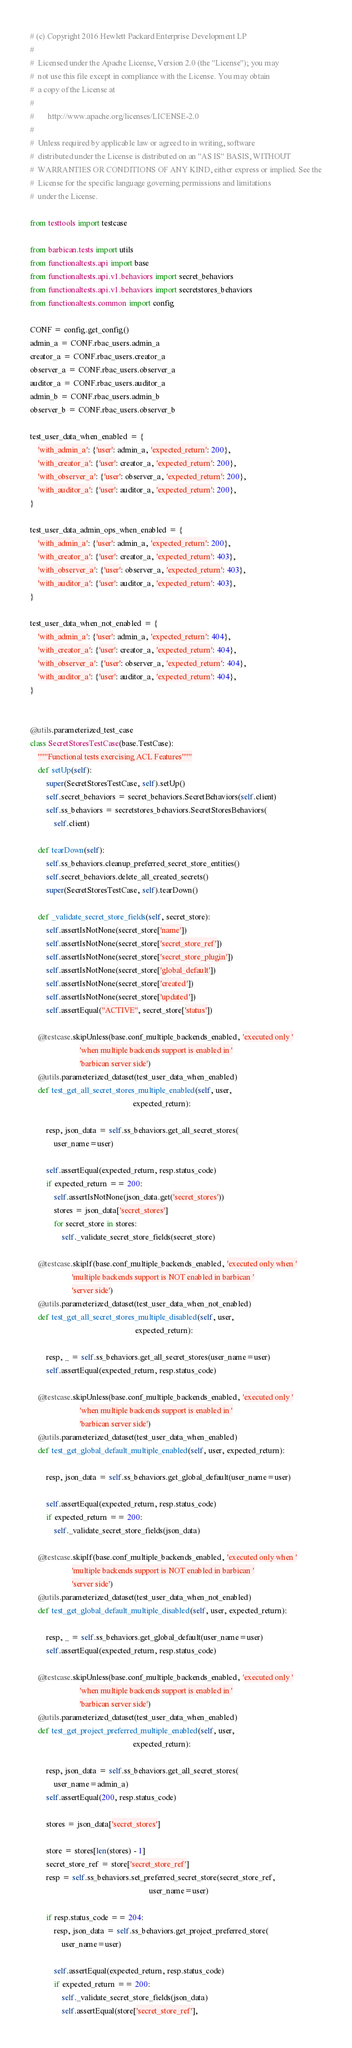Convert code to text. <code><loc_0><loc_0><loc_500><loc_500><_Python_># (c) Copyright 2016 Hewlett Packard Enterprise Development LP
#
#  Licensed under the Apache License, Version 2.0 (the "License"); you may
#  not use this file except in compliance with the License. You may obtain
#  a copy of the License at
#
#       http://www.apache.org/licenses/LICENSE-2.0
#
#  Unless required by applicable law or agreed to in writing, software
#  distributed under the License is distributed on an "AS IS" BASIS, WITHOUT
#  WARRANTIES OR CONDITIONS OF ANY KIND, either express or implied. See the
#  License for the specific language governing permissions and limitations
#  under the License.

from testtools import testcase

from barbican.tests import utils
from functionaltests.api import base
from functionaltests.api.v1.behaviors import secret_behaviors
from functionaltests.api.v1.behaviors import secretstores_behaviors
from functionaltests.common import config

CONF = config.get_config()
admin_a = CONF.rbac_users.admin_a
creator_a = CONF.rbac_users.creator_a
observer_a = CONF.rbac_users.observer_a
auditor_a = CONF.rbac_users.auditor_a
admin_b = CONF.rbac_users.admin_b
observer_b = CONF.rbac_users.observer_b

test_user_data_when_enabled = {
    'with_admin_a': {'user': admin_a, 'expected_return': 200},
    'with_creator_a': {'user': creator_a, 'expected_return': 200},
    'with_observer_a': {'user': observer_a, 'expected_return': 200},
    'with_auditor_a': {'user': auditor_a, 'expected_return': 200},
}

test_user_data_admin_ops_when_enabled = {
    'with_admin_a': {'user': admin_a, 'expected_return': 200},
    'with_creator_a': {'user': creator_a, 'expected_return': 403},
    'with_observer_a': {'user': observer_a, 'expected_return': 403},
    'with_auditor_a': {'user': auditor_a, 'expected_return': 403},
}

test_user_data_when_not_enabled = {
    'with_admin_a': {'user': admin_a, 'expected_return': 404},
    'with_creator_a': {'user': creator_a, 'expected_return': 404},
    'with_observer_a': {'user': observer_a, 'expected_return': 404},
    'with_auditor_a': {'user': auditor_a, 'expected_return': 404},
}


@utils.parameterized_test_case
class SecretStoresTestCase(base.TestCase):
    """Functional tests exercising ACL Features"""
    def setUp(self):
        super(SecretStoresTestCase, self).setUp()
        self.secret_behaviors = secret_behaviors.SecretBehaviors(self.client)
        self.ss_behaviors = secretstores_behaviors.SecretStoresBehaviors(
            self.client)

    def tearDown(self):
        self.ss_behaviors.cleanup_preferred_secret_store_entities()
        self.secret_behaviors.delete_all_created_secrets()
        super(SecretStoresTestCase, self).tearDown()

    def _validate_secret_store_fields(self, secret_store):
        self.assertIsNotNone(secret_store['name'])
        self.assertIsNotNone(secret_store['secret_store_ref'])
        self.assertIsNotNone(secret_store['secret_store_plugin'])
        self.assertIsNotNone(secret_store['global_default'])
        self.assertIsNotNone(secret_store['created'])
        self.assertIsNotNone(secret_store['updated'])
        self.assertEqual("ACTIVE", secret_store['status'])

    @testcase.skipUnless(base.conf_multiple_backends_enabled, 'executed only '
                         'when multiple backends support is enabled in '
                         'barbican server side')
    @utils.parameterized_dataset(test_user_data_when_enabled)
    def test_get_all_secret_stores_multiple_enabled(self, user,
                                                    expected_return):

        resp, json_data = self.ss_behaviors.get_all_secret_stores(
            user_name=user)

        self.assertEqual(expected_return, resp.status_code)
        if expected_return == 200:
            self.assertIsNotNone(json_data.get('secret_stores'))
            stores = json_data['secret_stores']
            for secret_store in stores:
                self._validate_secret_store_fields(secret_store)

    @testcase.skipIf(base.conf_multiple_backends_enabled, 'executed only when '
                     'multiple backends support is NOT enabled in barbican '
                     'server side')
    @utils.parameterized_dataset(test_user_data_when_not_enabled)
    def test_get_all_secret_stores_multiple_disabled(self, user,
                                                     expected_return):

        resp, _ = self.ss_behaviors.get_all_secret_stores(user_name=user)
        self.assertEqual(expected_return, resp.status_code)

    @testcase.skipUnless(base.conf_multiple_backends_enabled, 'executed only '
                         'when multiple backends support is enabled in '
                         'barbican server side')
    @utils.parameterized_dataset(test_user_data_when_enabled)
    def test_get_global_default_multiple_enabled(self, user, expected_return):

        resp, json_data = self.ss_behaviors.get_global_default(user_name=user)

        self.assertEqual(expected_return, resp.status_code)
        if expected_return == 200:
            self._validate_secret_store_fields(json_data)

    @testcase.skipIf(base.conf_multiple_backends_enabled, 'executed only when '
                     'multiple backends support is NOT enabled in barbican '
                     'server side')
    @utils.parameterized_dataset(test_user_data_when_not_enabled)
    def test_get_global_default_multiple_disabled(self, user, expected_return):

        resp, _ = self.ss_behaviors.get_global_default(user_name=user)
        self.assertEqual(expected_return, resp.status_code)

    @testcase.skipUnless(base.conf_multiple_backends_enabled, 'executed only '
                         'when multiple backends support is enabled in '
                         'barbican server side')
    @utils.parameterized_dataset(test_user_data_when_enabled)
    def test_get_project_preferred_multiple_enabled(self, user,
                                                    expected_return):

        resp, json_data = self.ss_behaviors.get_all_secret_stores(
            user_name=admin_a)
        self.assertEqual(200, resp.status_code)

        stores = json_data['secret_stores']

        store = stores[len(stores) - 1]
        secret_store_ref = store['secret_store_ref']
        resp = self.ss_behaviors.set_preferred_secret_store(secret_store_ref,
                                                            user_name=user)

        if resp.status_code == 204:
            resp, json_data = self.ss_behaviors.get_project_preferred_store(
                user_name=user)

            self.assertEqual(expected_return, resp.status_code)
            if expected_return == 200:
                self._validate_secret_store_fields(json_data)
                self.assertEqual(store['secret_store_ref'],</code> 